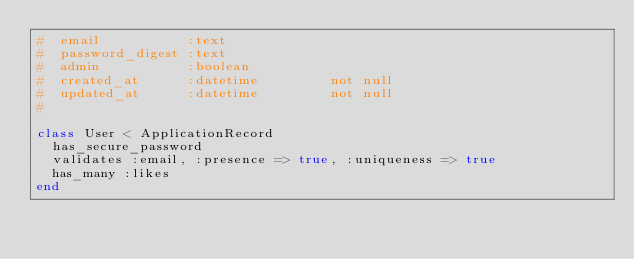<code> <loc_0><loc_0><loc_500><loc_500><_Ruby_>#  email           :text
#  password_digest :text
#  admin           :boolean
#  created_at      :datetime         not null
#  updated_at      :datetime         not null
#

class User < ApplicationRecord
  has_secure_password
  validates :email, :presence => true, :uniqueness => true
  has_many :likes
end
</code> 